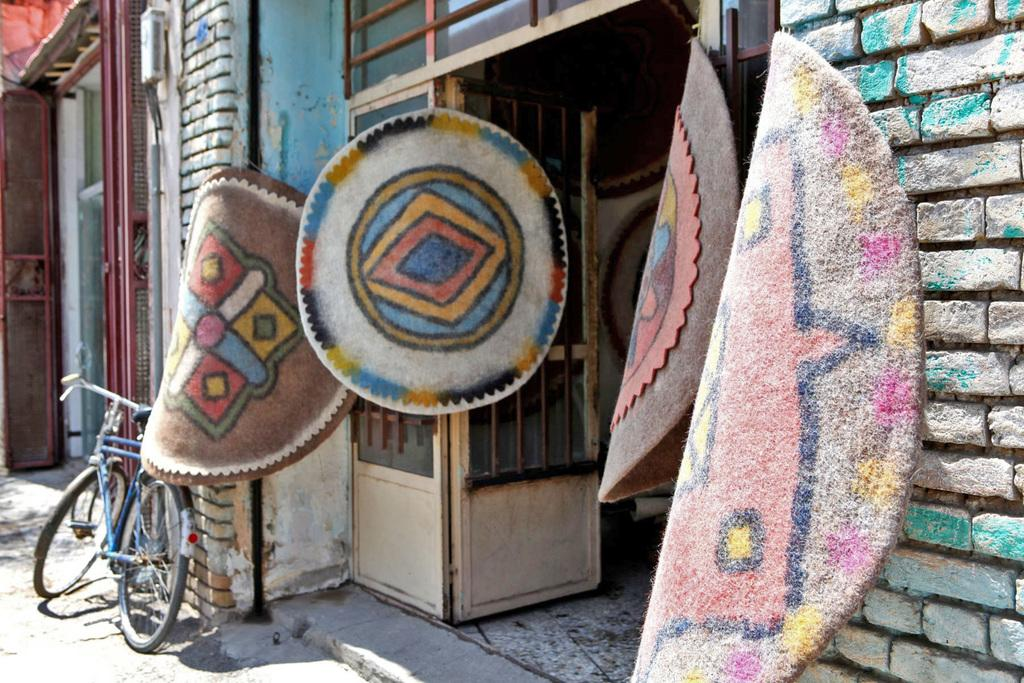What type of structures are visible in the image? There are buildings in the image. What can be found on the buildings in the image? There are doors on the buildings in the image. What type of flooring is present in the image? There are mats in the image. What mode of transportation is visible in front of the building? There is a cycle in front of the building. How many spies can be seen hiding behind the buildings in the image? There are no spies visible in the image; it only shows buildings, doors, mats, and a cycle. 